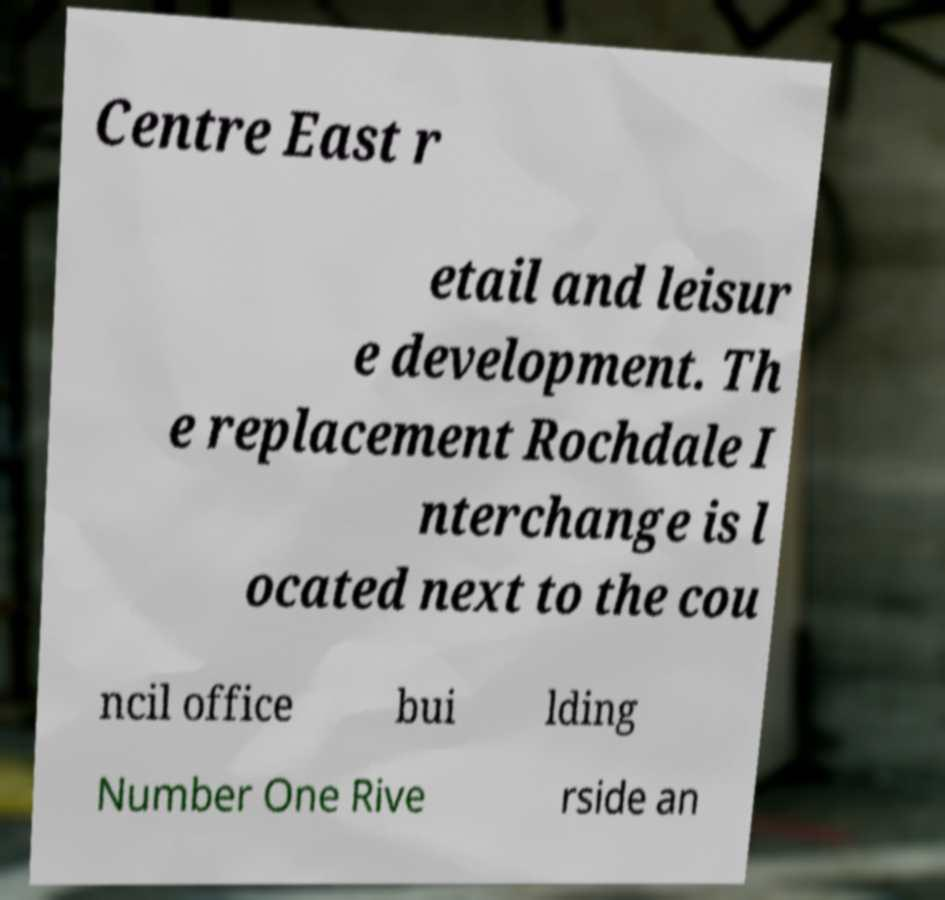Please identify and transcribe the text found in this image. Centre East r etail and leisur e development. Th e replacement Rochdale I nterchange is l ocated next to the cou ncil office bui lding Number One Rive rside an 